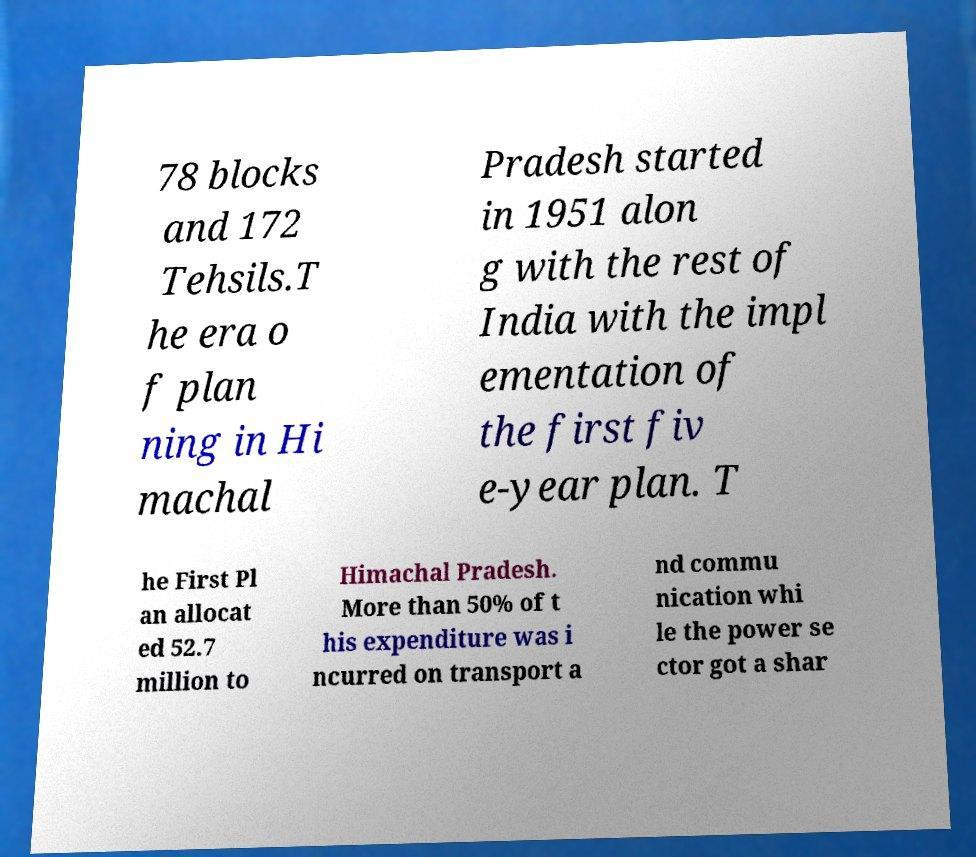Can you read and provide the text displayed in the image?This photo seems to have some interesting text. Can you extract and type it out for me? 78 blocks and 172 Tehsils.T he era o f plan ning in Hi machal Pradesh started in 1951 alon g with the rest of India with the impl ementation of the first fiv e-year plan. T he First Pl an allocat ed 52.7 million to Himachal Pradesh. More than 50% of t his expenditure was i ncurred on transport a nd commu nication whi le the power se ctor got a shar 